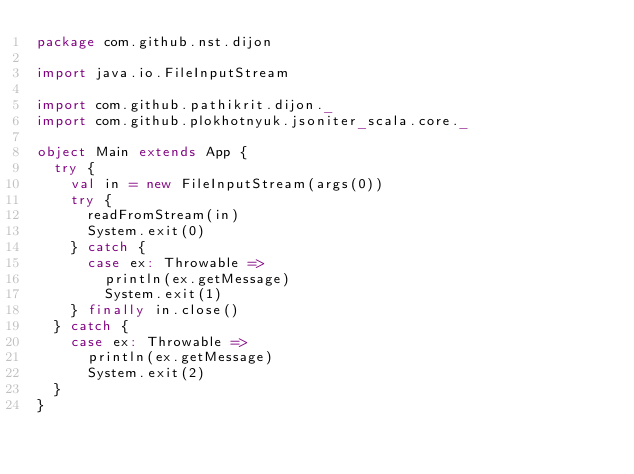<code> <loc_0><loc_0><loc_500><loc_500><_Scala_>package com.github.nst.dijon

import java.io.FileInputStream

import com.github.pathikrit.dijon._
import com.github.plokhotnyuk.jsoniter_scala.core._

object Main extends App {
  try {
    val in = new FileInputStream(args(0))
    try {
      readFromStream(in)
      System.exit(0)
    } catch {
      case ex: Throwable =>
        println(ex.getMessage)
        System.exit(1)
    } finally in.close()
  } catch {
    case ex: Throwable =>
      println(ex.getMessage)
      System.exit(2)
  }
}
</code> 